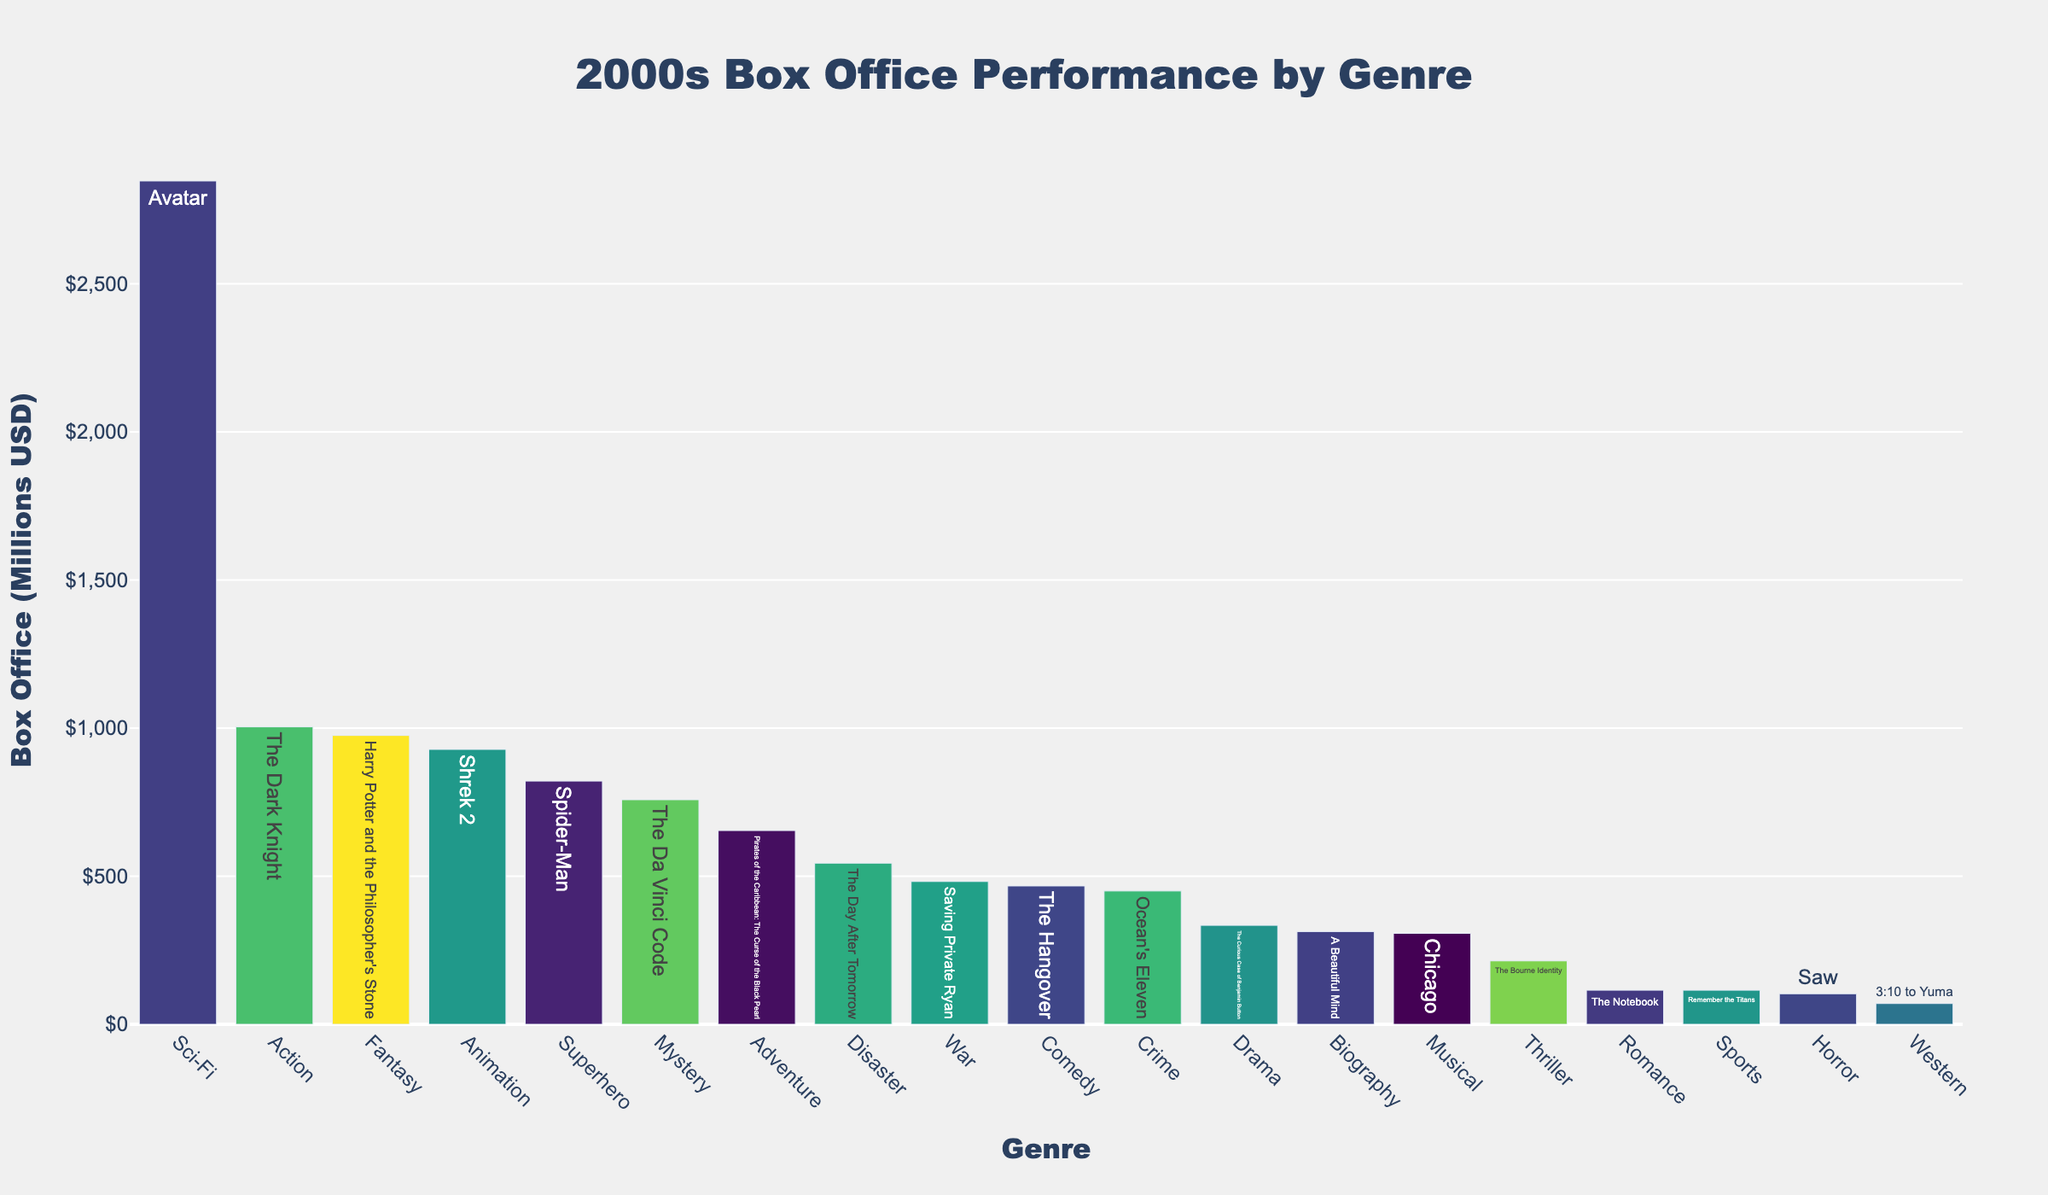What is the title of the plot? The title is located at the top center of the plot, displaying the overall theme or subject. It reads "2000s Box Office Performance by Genre."
Answer: 2000s Box Office Performance by Genre Which genre has the highest box office performance? One can identify the genre with the highest bar in the plot. The Sci-Fi genre, specifically "Avatar" from 2009, has the highest box office performance.
Answer: Sci-Fi What is the box office performance of the highest-grossing film? By hovering over the top bar in the plot, it shows "Avatar (2009) - Box Office: $2,847M," representing the highest-grossing film.
Answer: $2,847M Which genre has the lowest box office performance, and what is the value? The shortest bar in the plot represents the lowest box office performance. The "Western" genre, specifically "3:10 to Yuma" from 2007, has the lowest box office performance. By hovering over the bar, it shows a box office value of $70M.
Answer: Western, $70M How does the box office performance of "Pirates of the Caribbean: The Curse of the Black Pearl" compare to "Harry Potter and the Philosopher's Stone"? Comparing the bars for "Adventure" and "Fantasy" genres, "Pirates of the Caribbean: The Curse of the Black Pearl" (from 2003) has a box office performance of $654M, whereas "Harry Potter and the Philosopher's Stone" (from 2001) has $975M.
Answer: Pirates: $654M; Harry Potter: $975M By how much did "The Day After Tomorrow" outperform "The Notebook"? Hovering over the bars for "Disaster" and "Romance" genres, "The Day After Tomorrow" had a box office performance of $544M while "The Notebook" had $115M. Subtracting these, $544M - $115M equals $429M.
Answer: $429M Which genres have films that grossed over $900 million? Hovering over the bars or inspecting their height, we see that genres "Action," "Sci-Fi," "Fantasy," and "Animation" have films that grossed over $900M (The Dark Knight, Avatar, Harry Potter and the Philosopher's Stone, and Shrek 2 respectively).
Answer: Action, Sci-Fi, Fantasy, Animation What is the average box office performance of the films listed? Adding up all box office performances and dividing by the total number of films. Sum = 1004 + 467 + 334 + 2847 + 115 + 103 + 928 + 975 + 214 + 307 + 654 + 450 + 482 + 313 + 758 + 821 + 115 + 70 + 544. Total films = 19. Average = 12,501 / 19 ≈ 657.9M.
Answer: $657.9M Compare the box office performances of the top three grossing films. Observing the tallest bars: Sci-Fi's "Avatar" ($2,847M), Action's "The Dark Knight" ($1,004M), Fantasy's "Harry Potter and the Philosopher's Stone" ($975M).
Answer: Avatar: $2,847M; The Dark Knight: $1,004M; Harry Potter: $975M Which year had the highest number of high-grossing films above $500 million? Counting the films within each year surpassing $500M by hovering over the respective bars: 2004 (Shrek 2: $928M, The Day After Tomorrow: $544M) and 2008 (The Dark Knight: $1,004M, The Curious Case of Benjamin Button: $334M). Other years have fewer films above $500M.
Answer: 2004 (tie with 2008 based on $500M threshold but 2004 had multiple higher performers closely observed) 